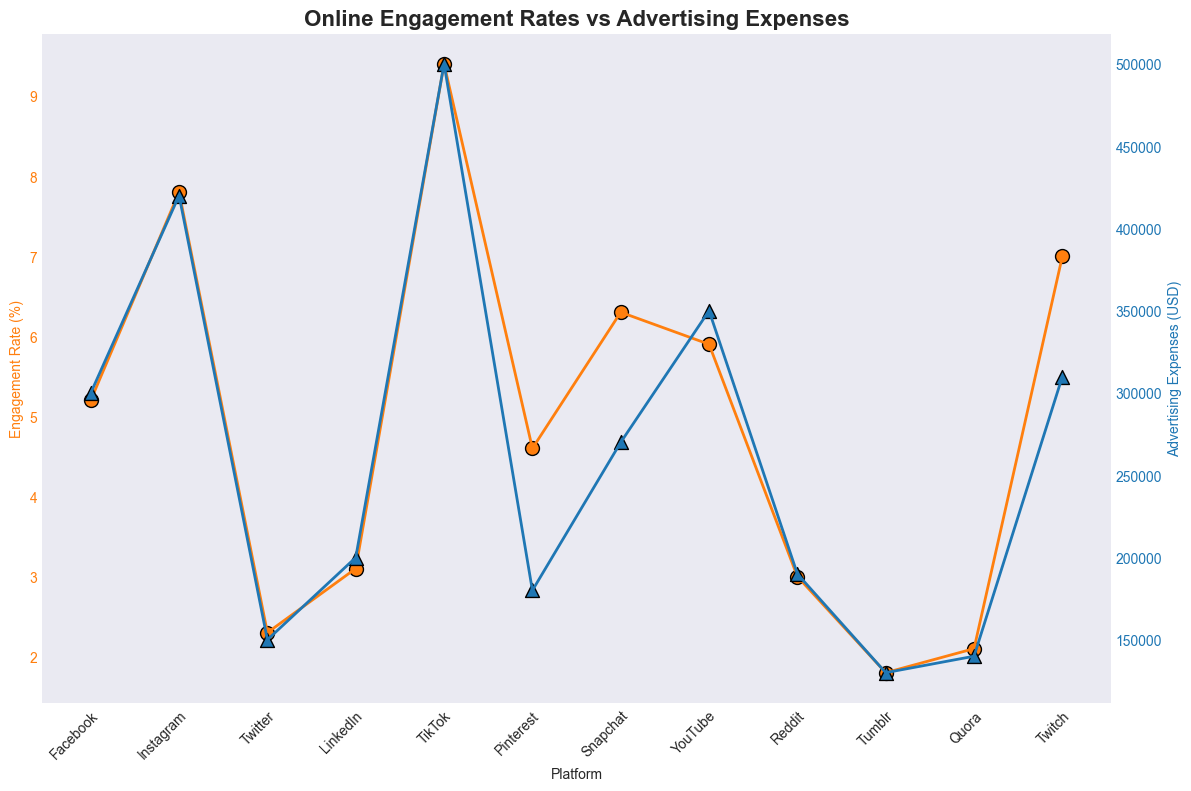Which platform has the highest engagement rate? The platform with the highest engagement rate can be identified by looking at the topmost data point on the Engagement Rate (%) axis. TikTok shows the highest engagement rate with 9.4%.
Answer: TikTok Which platform has the lowest advertising expenses? The platform with the lowest advertising expenses can be identified by looking at the bottommost data point on the Advertising Expenses (USD) axis. Tumblr shows the lowest advertising expenses with $130,000.
Answer: Tumblr What is the difference in engagement rates between Instagram and Snapchat? Refer to the engagement rate values for Instagram and Snapchat. Instagram has a rate of 7.8%, while Snapchat has 6.3%. The difference is calculated as 7.8% - 6.3% = 1.5%.
Answer: 1.5% Which platform shows a higher engagement rate than Facebook but lower than TikTok? Compare the engagement rates of platforms within the range greater than 5.2% (Facebook) and less than 9.4% (TikTok). Instagram, Snapchat, and YouTube fall in this range.
Answer: Instagram, Snapchat, YouTube What is the average engagement rate for LinkedIn, Reddit, and Tumblr? Look at the engagement rates for LinkedIn (3.1%), Reddit (3.0%), and Tumblr (1.8%). The sum is 3.1 + 3.0 + 1.8 = 7.9. The average is 7.9 / 3 ≈ 2.63%.
Answer: 2.63% Which platform has an advertising expense closest to that of Facebook? Compare the advertising expenses of all platforms to find the one nearest $300,000 (Facebook). Twitch has advertising expenses of $310,000, which is the closest.
Answer: Twitch Is there a correlation between high engagement rates and high advertising expenses? By visually inspecting the figure, platforms with higher engagement rates like TikTok and Instagram also show higher advertising expenses, indicating a positive correlation. Note that this observation is qualitative and needs statistical analysis for confirmation.
Answer: Yes, generally Which platforms have an engagement rate below 3%? Identify platforms with engagement rates less than 3% by examining the Engagement Rate (%) axis. Twitter (2.3%), Tumblr (1.8%), Quora (2.1%), and Reddit (3.0%).
Answer: Twitter, Tumblr, Quora What is the total advertising expense across all platforms? Sum all advertising expenses: 300,000 (Facebook) + 420,000 (Instagram) + 150,000 (Twitter) + 200,000 (LinkedIn) + 500,000 (TikTok) + 180,000 (Pinterest) + 270,000 (Snapchat) + 350,000 (YouTube) + 190,000 (Reddit) + 130,000 (Tumblr) + 140,000 (Quora) + 310,000 (Twitch) = 3,140,000 USD.
Answer: 3,140,000 USD Which platform has a higher engagement rate, Pinterest or YouTube? Compare the engagement rates of Pinterest and YouTube. Pinterest has 4.6% and YouTube has 5.9%. YouTube has the higher engagement rate.
Answer: YouTube 